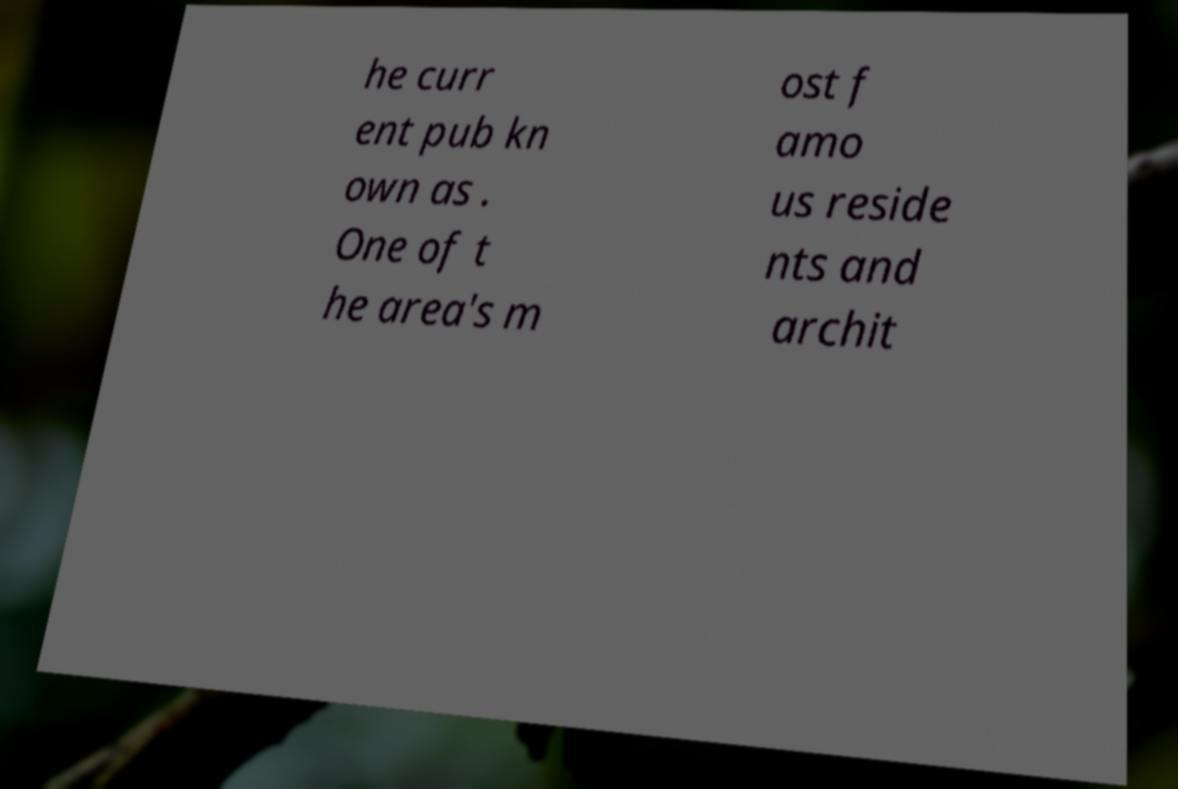What messages or text are displayed in this image? I need them in a readable, typed format. he curr ent pub kn own as . One of t he area's m ost f amo us reside nts and archit 